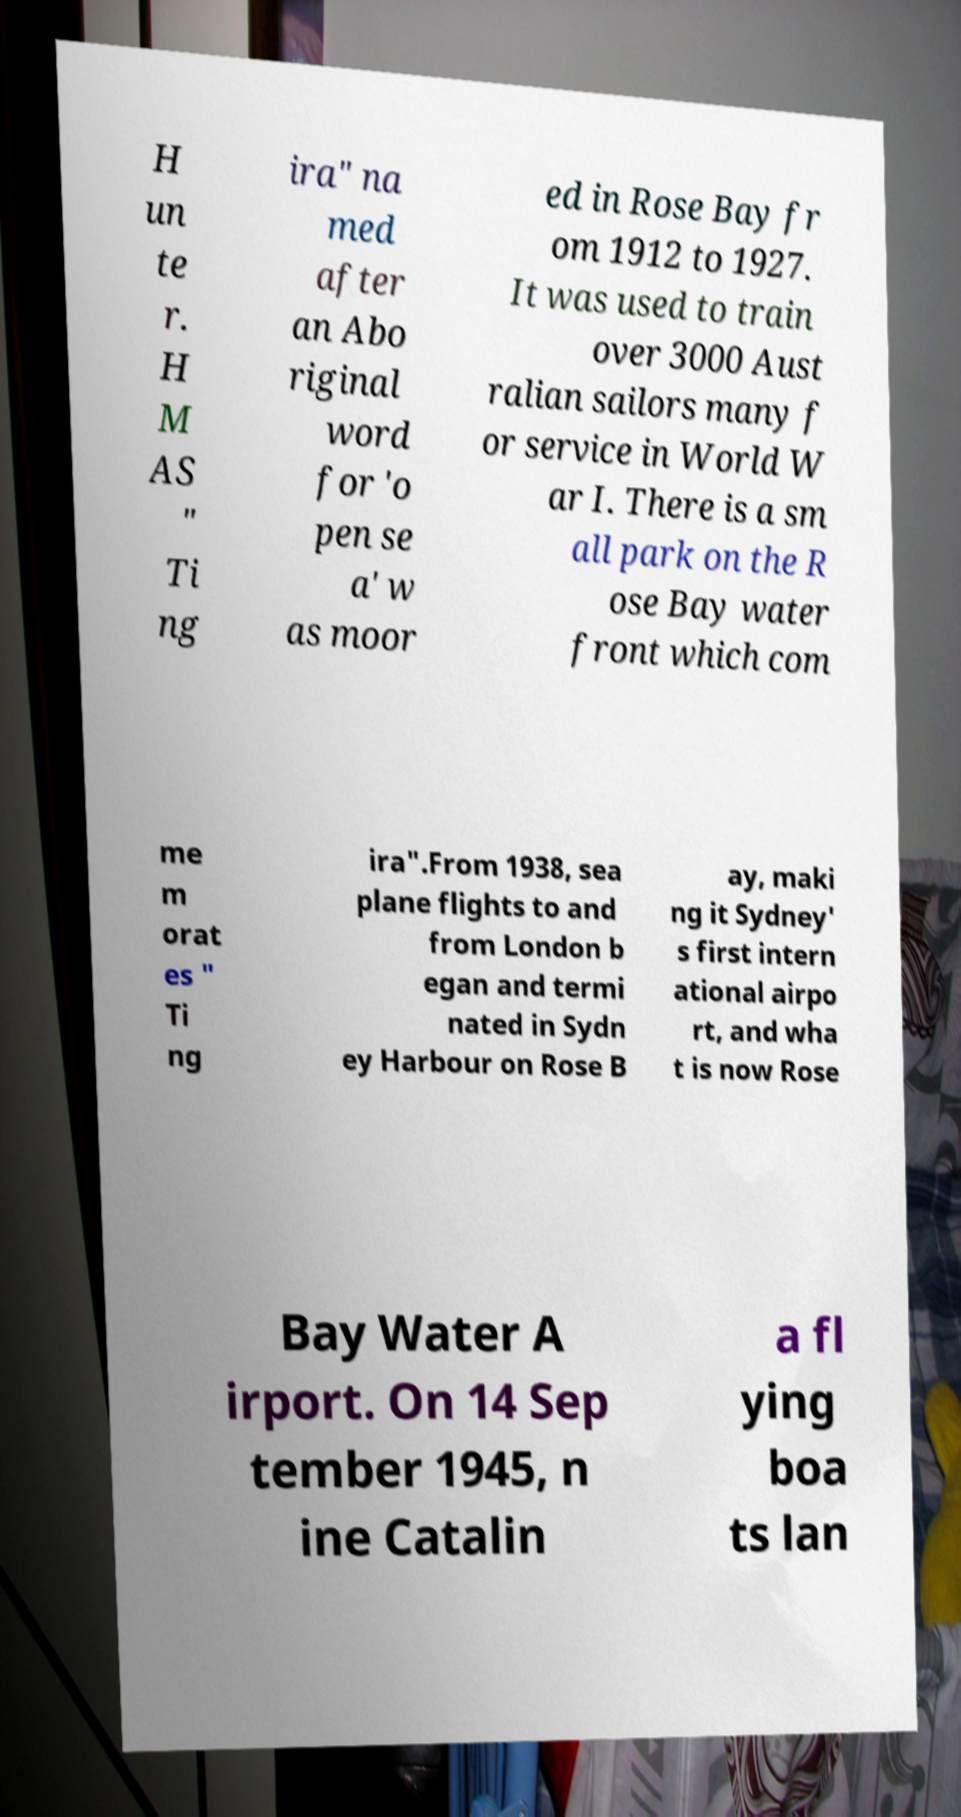Could you assist in decoding the text presented in this image and type it out clearly? H un te r. H M AS " Ti ng ira" na med after an Abo riginal word for 'o pen se a' w as moor ed in Rose Bay fr om 1912 to 1927. It was used to train over 3000 Aust ralian sailors many f or service in World W ar I. There is a sm all park on the R ose Bay water front which com me m orat es " Ti ng ira".From 1938, sea plane flights to and from London b egan and termi nated in Sydn ey Harbour on Rose B ay, maki ng it Sydney' s first intern ational airpo rt, and wha t is now Rose Bay Water A irport. On 14 Sep tember 1945, n ine Catalin a fl ying boa ts lan 